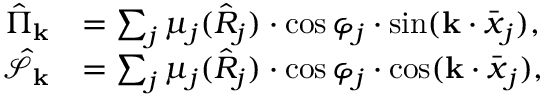<formula> <loc_0><loc_0><loc_500><loc_500>\begin{array} { r l } { \hat { \Pi } _ { k } } & { = \sum _ { j } \mu _ { j } ( \hat { R } _ { j } ) \cdot \cos \varphi _ { j } \cdot \sin ( k \cdot \bar { \boldsymbol x } _ { j } ) , } \\ { \hat { \mathcal { S } } _ { k } } & { = \sum _ { j } \mu _ { j } ( \hat { R } _ { j } ) \cdot \cos \varphi _ { j } \cdot \cos ( k \cdot \bar { \boldsymbol x } _ { j } ) , } \end{array}</formula> 